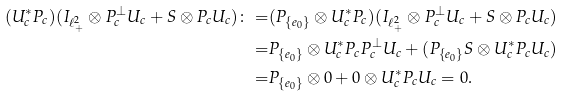<formula> <loc_0><loc_0><loc_500><loc_500>( U _ { c } ^ { * } P _ { c } ) ( I _ { \ell ^ { 2 } _ { + } } \otimes P _ { c } ^ { \perp } U _ { c } + S \otimes P _ { c } U _ { c } ) \colon = & ( P _ { \{ e _ { 0 } \} } \otimes U _ { c } ^ { * } P _ { c } ) ( I _ { \ell ^ { 2 } _ { + } } \otimes P _ { c } ^ { \perp } U _ { c } + S \otimes P _ { c } U _ { c } ) \\ = & P _ { \{ e _ { 0 } \} } \otimes U _ { c } ^ { * } P _ { c } P _ { c } ^ { \perp } U _ { c } + ( P _ { \{ e _ { 0 } \} } S \otimes U _ { c } ^ { * } P _ { c } U _ { c } ) \\ = & P _ { \{ e _ { 0 } \} } \otimes 0 + 0 \otimes U _ { c } ^ { * } P _ { c } U _ { c } = 0 .</formula> 